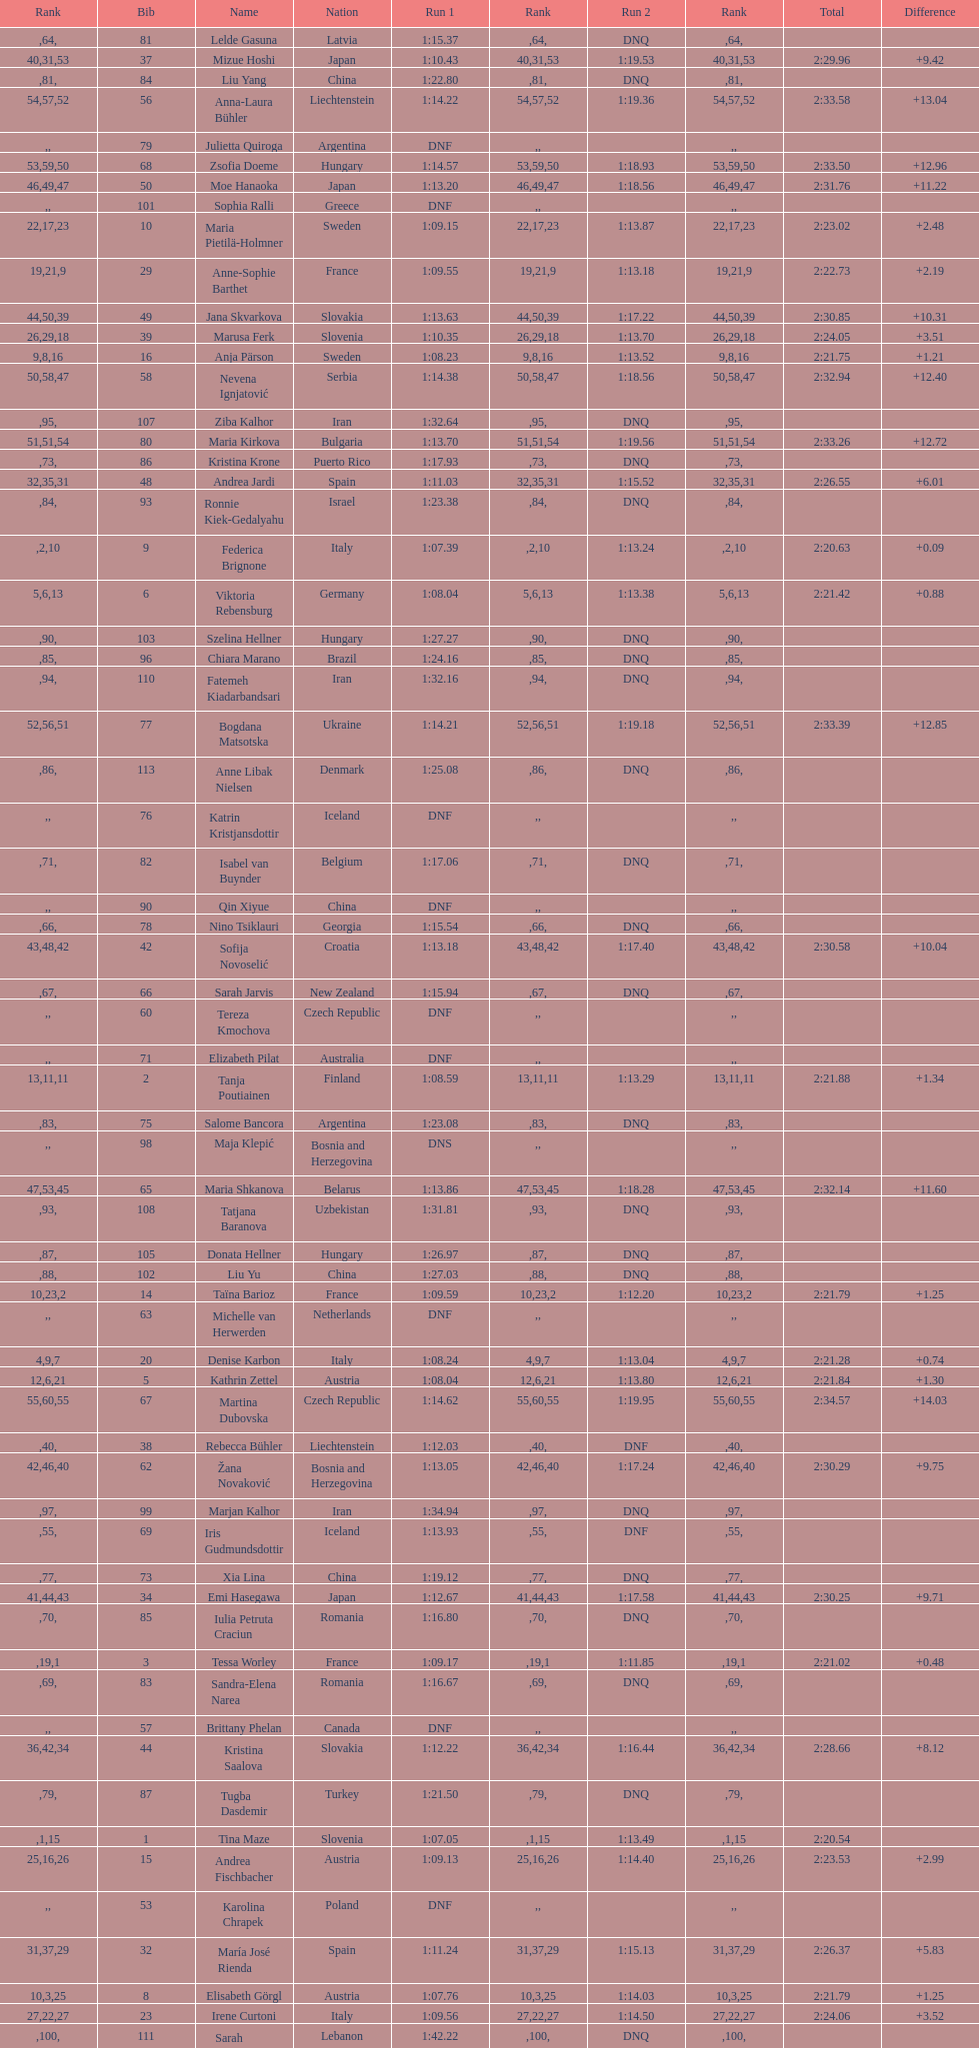What is the last nation to be ranked? Czech Republic. 